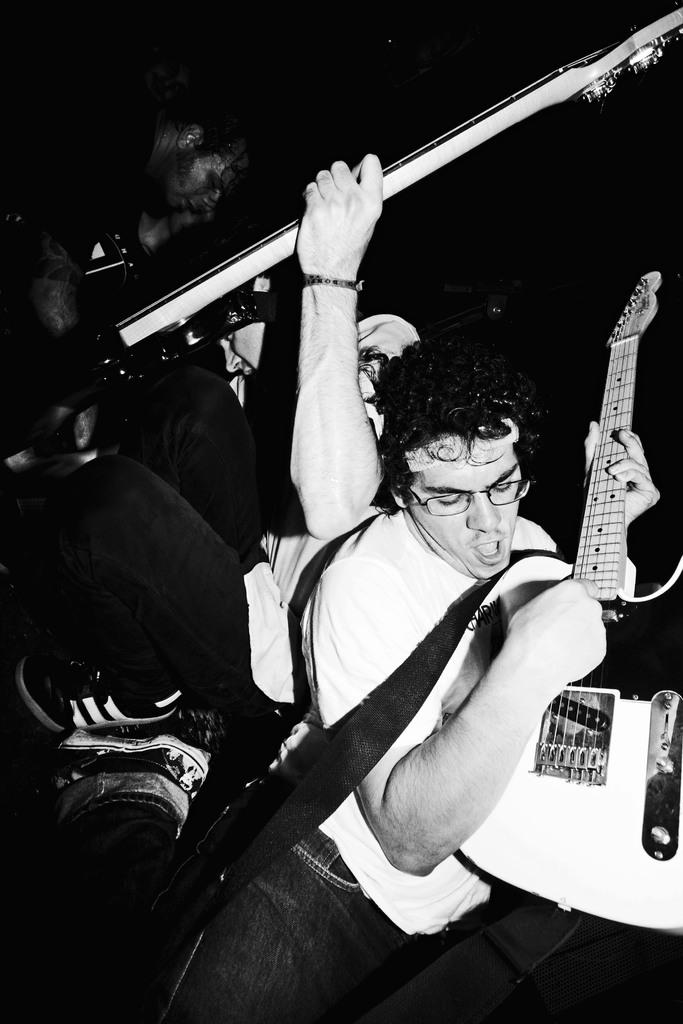What is the person in the image holding with one hand? The person is holding a guitar with one hand. How is the person interacting with the guitar? The person's mouth is visible in the image, which suggests they might be singing or playing the guitar. What can be seen on the person's face? The person is wearing spectacles. Can you describe the second person in the image? The second person is holding a rod in their hand. What type of coal is being used to fuel the system in the image? There is no coal or system present in the image; it features a person holding a guitar and another person holding a rod. 